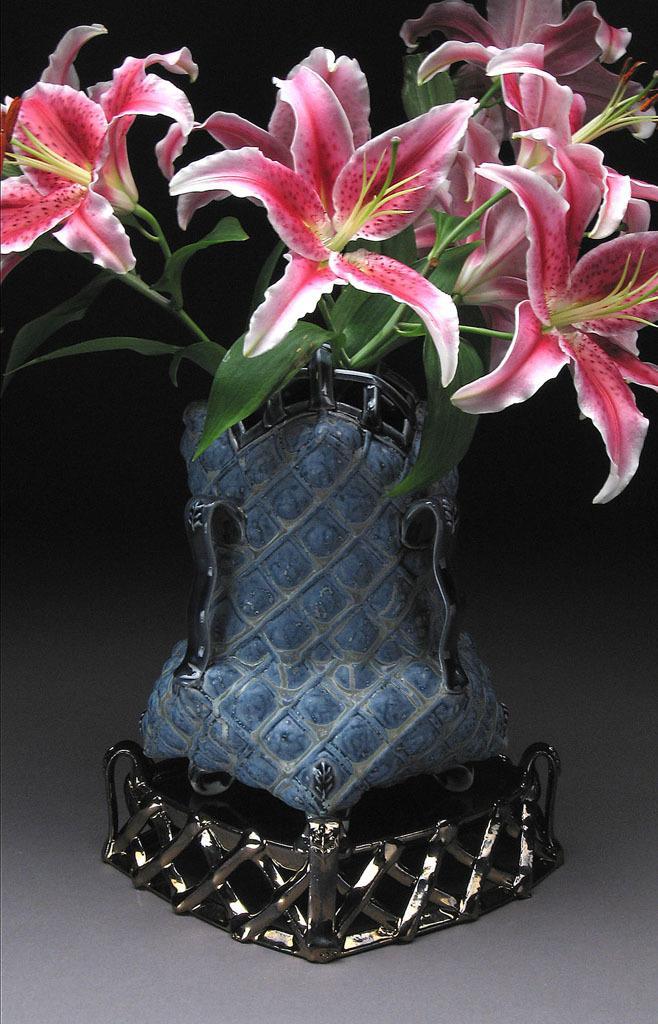Can you describe this image briefly? In this image, this looks like a flower vase with a bunch of flowers in it. These flowers are pinkish in color. The background looks dark. 